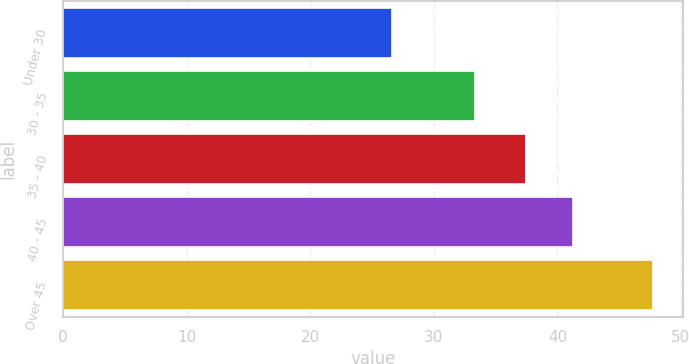Convert chart. <chart><loc_0><loc_0><loc_500><loc_500><bar_chart><fcel>Under 30<fcel>30 - 35<fcel>35 - 40<fcel>40 - 45<fcel>Over 45<nl><fcel>26.6<fcel>33.3<fcel>37.42<fcel>41.26<fcel>47.77<nl></chart> 